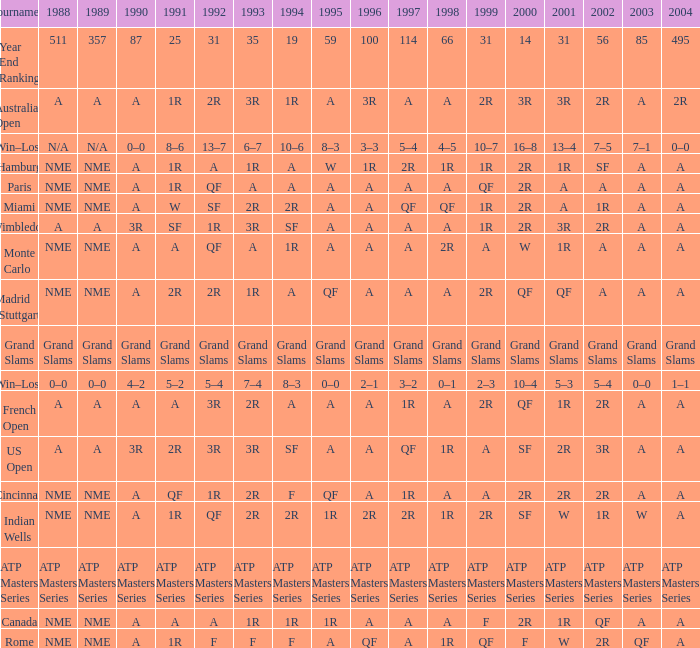What shows for 202 when the 1994 is A, the 1989 is NME, and the 199 is 2R? A. 